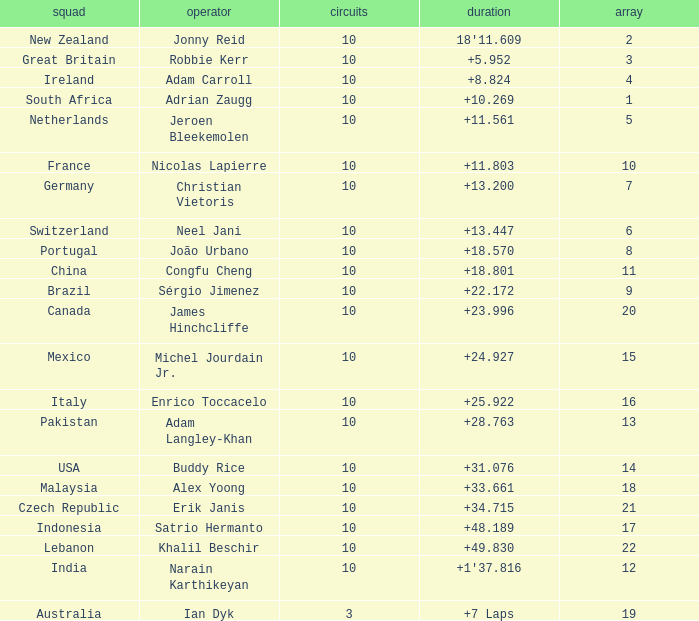For what Team is Narain Karthikeyan the Driver? India. Give me the full table as a dictionary. {'header': ['squad', 'operator', 'circuits', 'duration', 'array'], 'rows': [['New Zealand', 'Jonny Reid', '10', "18'11.609", '2'], ['Great Britain', 'Robbie Kerr', '10', '+5.952', '3'], ['Ireland', 'Adam Carroll', '10', '+8.824', '4'], ['South Africa', 'Adrian Zaugg', '10', '+10.269', '1'], ['Netherlands', 'Jeroen Bleekemolen', '10', '+11.561', '5'], ['France', 'Nicolas Lapierre', '10', '+11.803', '10'], ['Germany', 'Christian Vietoris', '10', '+13.200', '7'], ['Switzerland', 'Neel Jani', '10', '+13.447', '6'], ['Portugal', 'João Urbano', '10', '+18.570', '8'], ['China', 'Congfu Cheng', '10', '+18.801', '11'], ['Brazil', 'Sérgio Jimenez', '10', '+22.172', '9'], ['Canada', 'James Hinchcliffe', '10', '+23.996', '20'], ['Mexico', 'Michel Jourdain Jr.', '10', '+24.927', '15'], ['Italy', 'Enrico Toccacelo', '10', '+25.922', '16'], ['Pakistan', 'Adam Langley-Khan', '10', '+28.763', '13'], ['USA', 'Buddy Rice', '10', '+31.076', '14'], ['Malaysia', 'Alex Yoong', '10', '+33.661', '18'], ['Czech Republic', 'Erik Janis', '10', '+34.715', '21'], ['Indonesia', 'Satrio Hermanto', '10', '+48.189', '17'], ['Lebanon', 'Khalil Beschir', '10', '+49.830', '22'], ['India', 'Narain Karthikeyan', '10', "+1'37.816", '12'], ['Australia', 'Ian Dyk', '3', '+7 Laps', '19']]} 